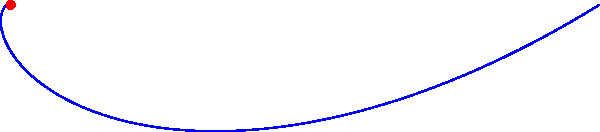In the spiral pattern shown above, which is based on the golden ratio, how many complete rotations around the center point are depicted? Consider how this visualization might relate to the harmonious patterns found in jazz music structures. To determine the number of complete rotations in the golden spiral, we need to analyze the given information and the visual representation:

1. The spiral is based on the golden ratio, approximately 1.618033988749895.
2. The equation for this type of spiral (logarithmic spiral) is typically represented as $r = ae^{b\theta}$, where $a$ and $b$ are constants, and $\theta$ is the angle in radians.
3. In the Asymptote code, we can see that the loop iterates from 0 to 360*n degrees, where n = 5.
4. Each complete rotation is 360 degrees.
5. Therefore, the total angle covered is 360 * 5 = 1800 degrees.
6. To convert this to complete rotations, we divide by 360:
   1800 / 360 = 5 complete rotations

This spiral pattern, with its 5 rotations, can be seen as an analogy to the structure of jazz music. Just as the golden ratio creates a harmonious visual pattern, jazz often employs complex yet balanced structures in its compositions, with themes and improvisations spiraling and evolving throughout a piece.
Answer: 5 rotations 